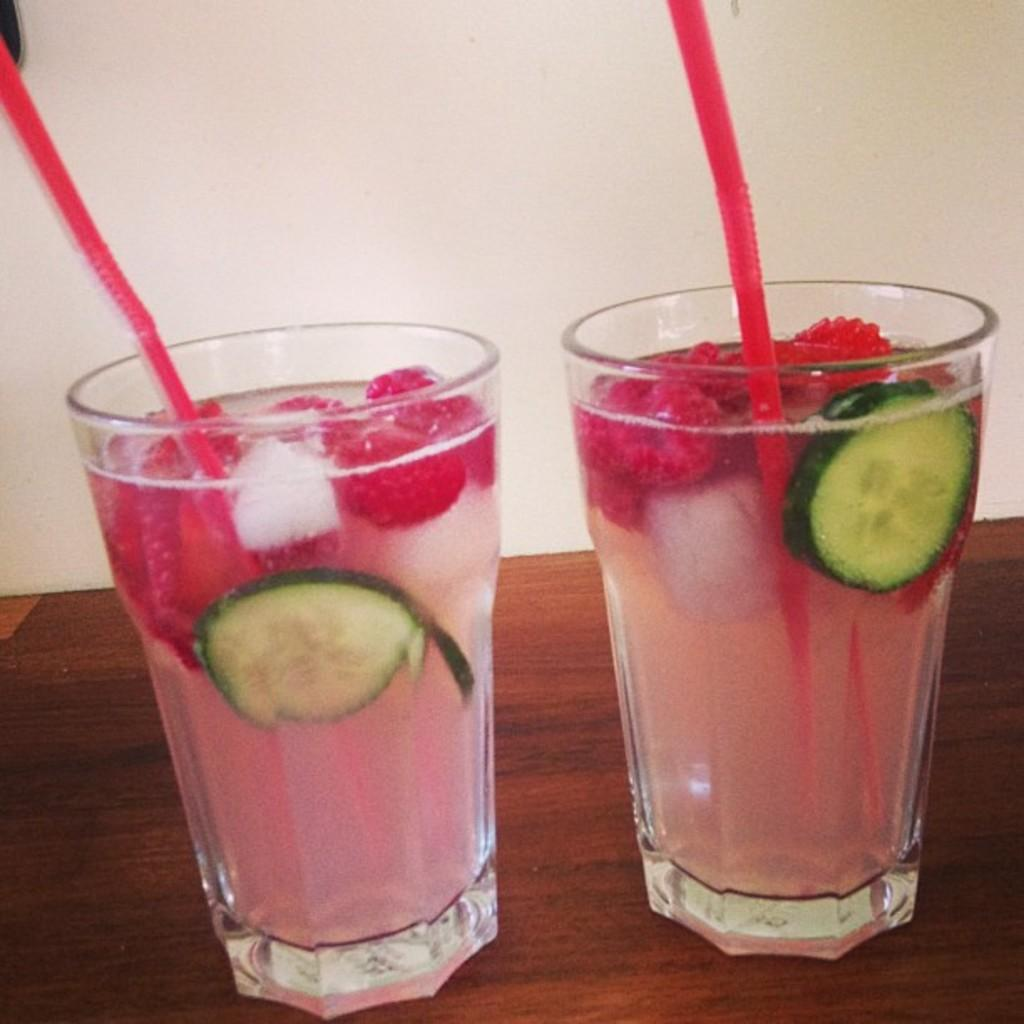What type of beverage containers are present in the image? There are two glass drinks in the image. How are the glass drinks being used? Each glass drink has a straw in it. Where are the glass drinks located? The glass drinks are placed on a table. What type of cap is the carpenter wearing in the image? There is no carpenter or cap present in the image. The image only features two glass drinks with straws, placed on a table. 